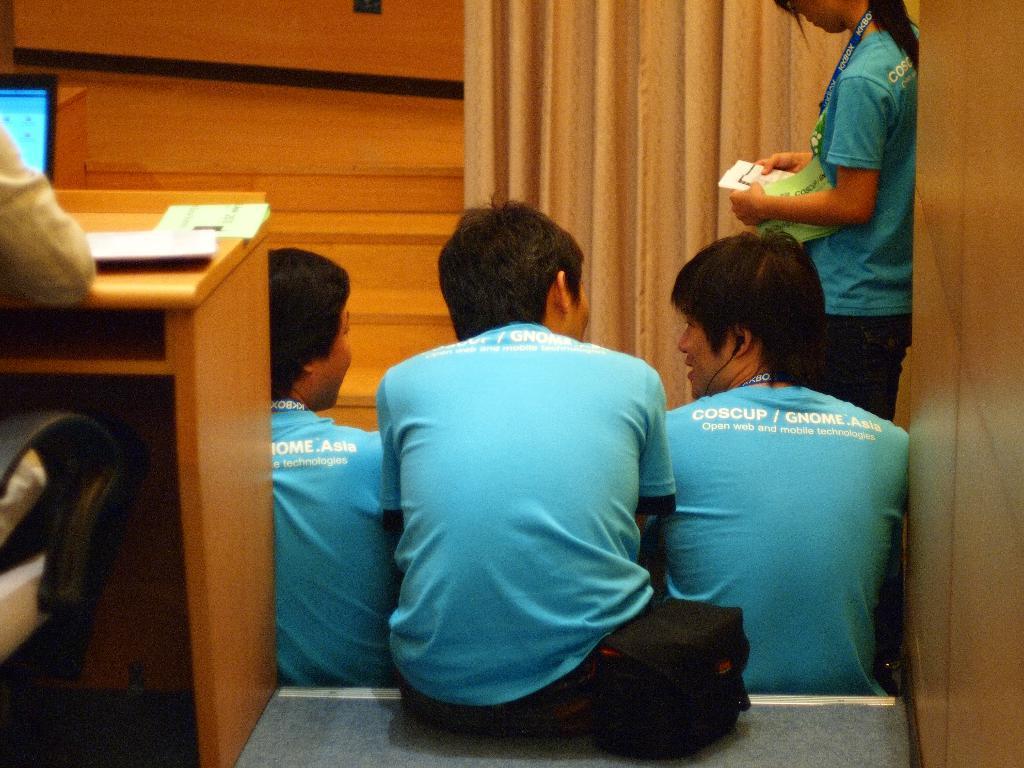Please provide a concise description of this image. in this picture we can see a group of persons sitting and a woman is standing ,in this picture we can also see table,on the table we can see some papers and a laptop,a person is working with a laptop. 